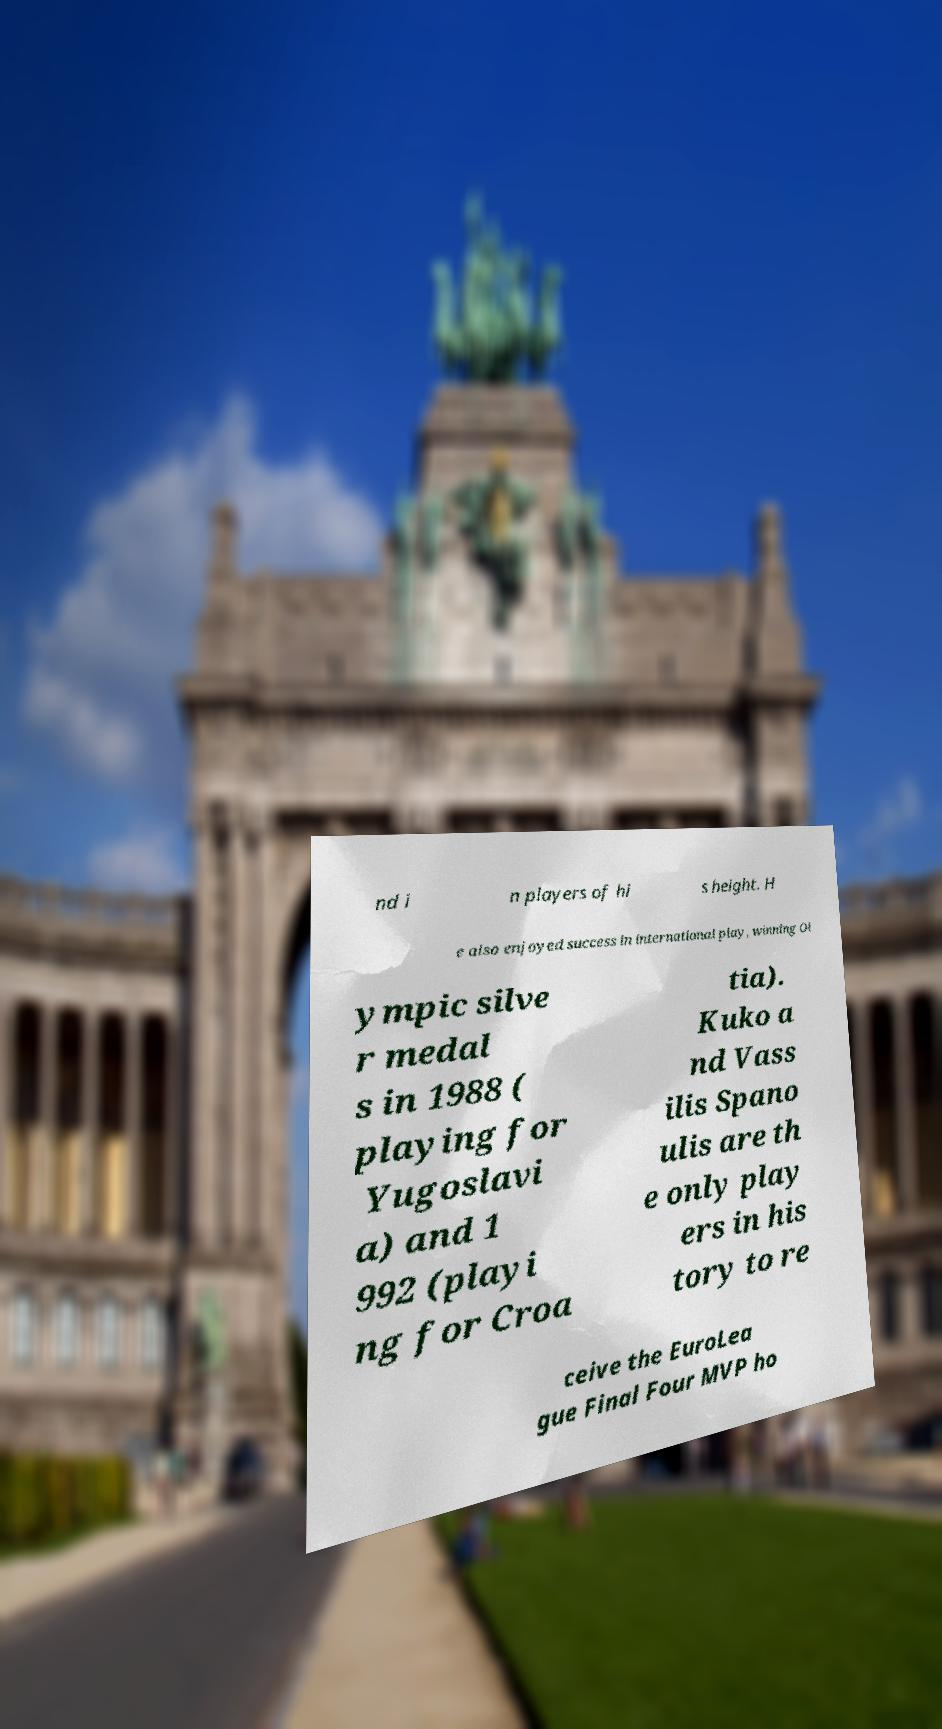I need the written content from this picture converted into text. Can you do that? nd i n players of hi s height. H e also enjoyed success in international play, winning Ol ympic silve r medal s in 1988 ( playing for Yugoslavi a) and 1 992 (playi ng for Croa tia). Kuko a nd Vass ilis Spano ulis are th e only play ers in his tory to re ceive the EuroLea gue Final Four MVP ho 